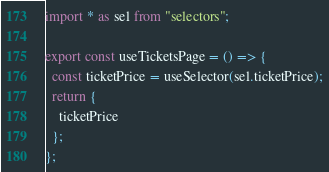<code> <loc_0><loc_0><loc_500><loc_500><_JavaScript_>import * as sel from "selectors";

export const useTicketsPage = () => {
  const ticketPrice = useSelector(sel.ticketPrice);
  return {
    ticketPrice
  };
};
</code> 